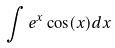Convert formula to latex. <formula><loc_0><loc_0><loc_500><loc_500>\int e ^ { x } \cos ( x ) d x</formula> 